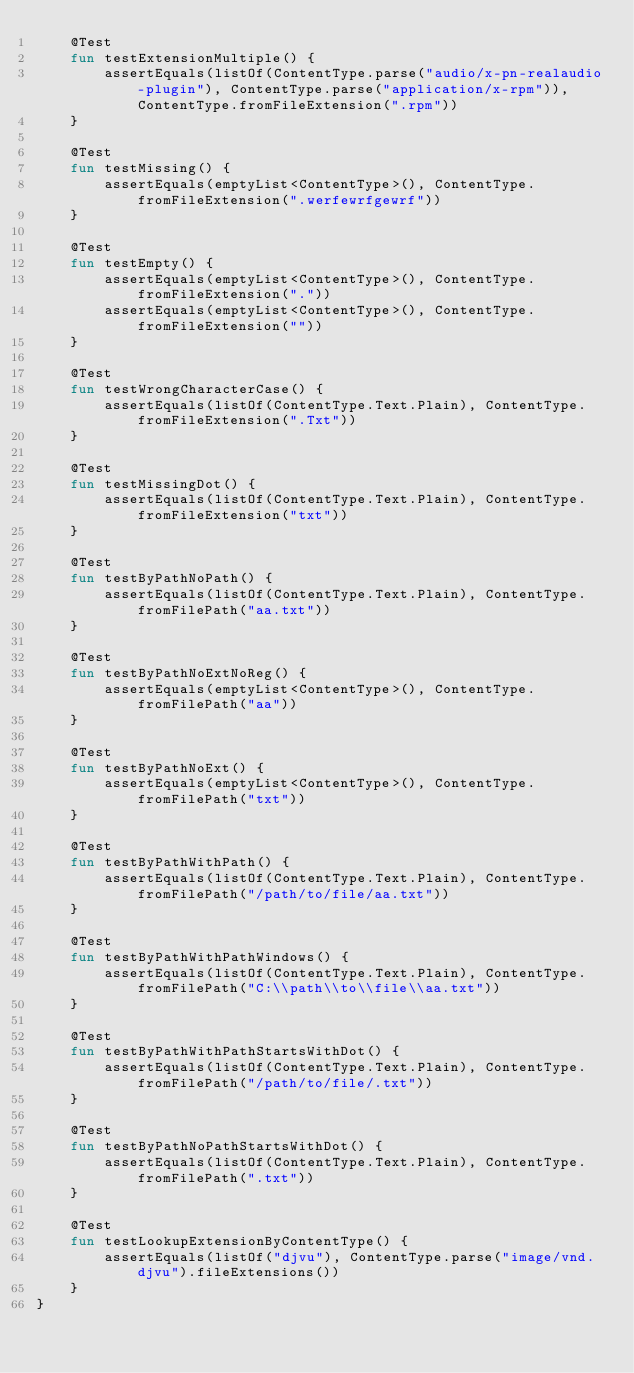<code> <loc_0><loc_0><loc_500><loc_500><_Kotlin_>    @Test
    fun testExtensionMultiple() {
        assertEquals(listOf(ContentType.parse("audio/x-pn-realaudio-plugin"), ContentType.parse("application/x-rpm")), ContentType.fromFileExtension(".rpm"))
    }

    @Test
    fun testMissing() {
        assertEquals(emptyList<ContentType>(), ContentType.fromFileExtension(".werfewrfgewrf"))
    }

    @Test
    fun testEmpty() {
        assertEquals(emptyList<ContentType>(), ContentType.fromFileExtension("."))
        assertEquals(emptyList<ContentType>(), ContentType.fromFileExtension(""))
    }

    @Test
    fun testWrongCharacterCase() {
        assertEquals(listOf(ContentType.Text.Plain), ContentType.fromFileExtension(".Txt"))
    }

    @Test
    fun testMissingDot() {
        assertEquals(listOf(ContentType.Text.Plain), ContentType.fromFileExtension("txt"))
    }

    @Test
    fun testByPathNoPath() {
        assertEquals(listOf(ContentType.Text.Plain), ContentType.fromFilePath("aa.txt"))
    }

    @Test
    fun testByPathNoExtNoReg() {
        assertEquals(emptyList<ContentType>(), ContentType.fromFilePath("aa"))
    }

    @Test
    fun testByPathNoExt() {
        assertEquals(emptyList<ContentType>(), ContentType.fromFilePath("txt"))
    }

    @Test
    fun testByPathWithPath() {
        assertEquals(listOf(ContentType.Text.Plain), ContentType.fromFilePath("/path/to/file/aa.txt"))
    }

    @Test
    fun testByPathWithPathWindows() {
        assertEquals(listOf(ContentType.Text.Plain), ContentType.fromFilePath("C:\\path\\to\\file\\aa.txt"))
    }

    @Test
    fun testByPathWithPathStartsWithDot() {
        assertEquals(listOf(ContentType.Text.Plain), ContentType.fromFilePath("/path/to/file/.txt"))
    }

    @Test
    fun testByPathNoPathStartsWithDot() {
        assertEquals(listOf(ContentType.Text.Plain), ContentType.fromFilePath(".txt"))
    }

    @Test
    fun testLookupExtensionByContentType() {
        assertEquals(listOf("djvu"), ContentType.parse("image/vnd.djvu").fileExtensions())
    }
}</code> 